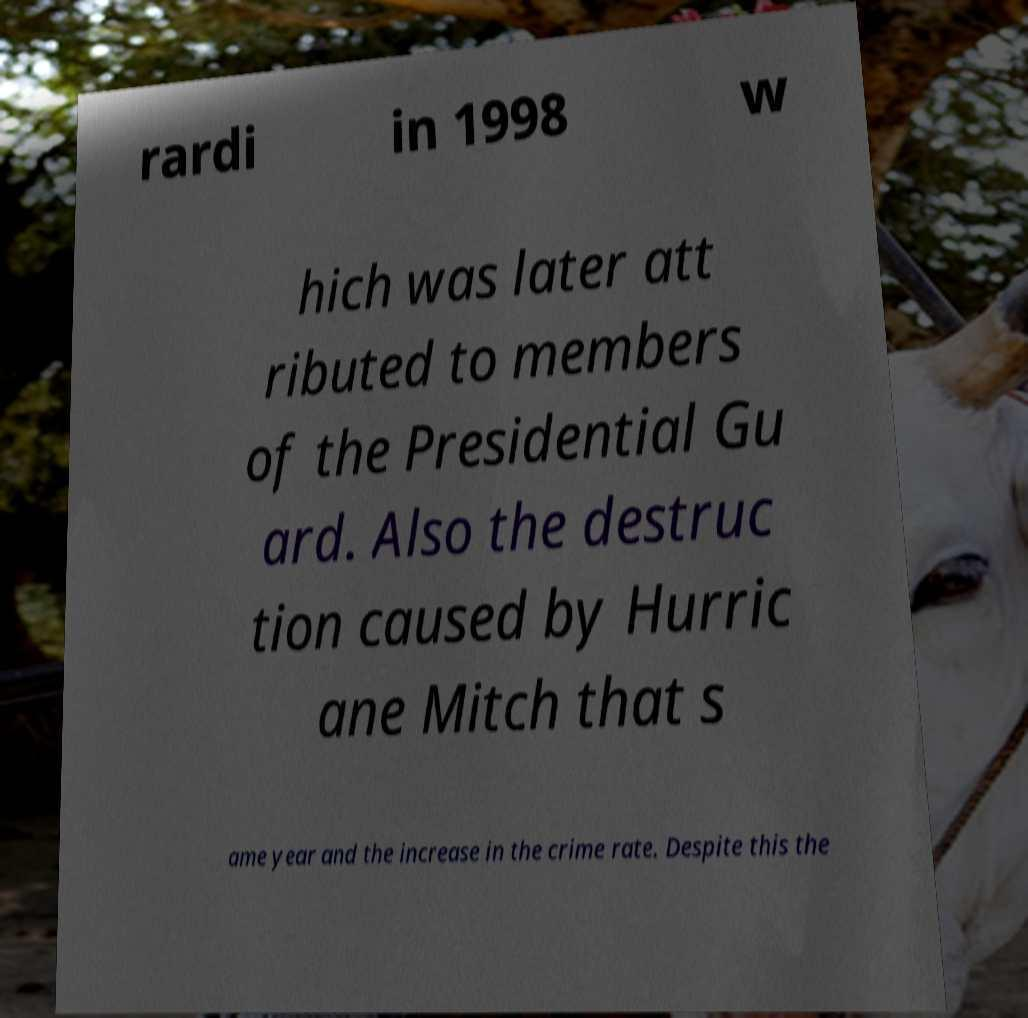Please identify and transcribe the text found in this image. rardi in 1998 w hich was later att ributed to members of the Presidential Gu ard. Also the destruc tion caused by Hurric ane Mitch that s ame year and the increase in the crime rate. Despite this the 